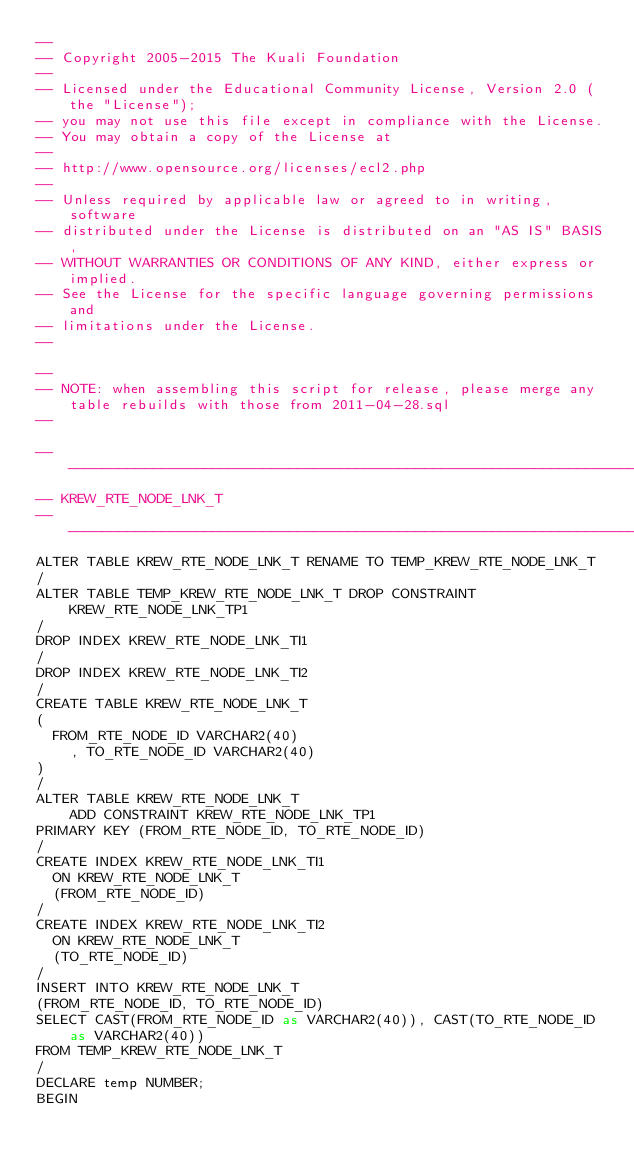Convert code to text. <code><loc_0><loc_0><loc_500><loc_500><_SQL_>--
-- Copyright 2005-2015 The Kuali Foundation
--
-- Licensed under the Educational Community License, Version 2.0 (the "License");
-- you may not use this file except in compliance with the License.
-- You may obtain a copy of the License at
--
-- http://www.opensource.org/licenses/ecl2.php
--
-- Unless required by applicable law or agreed to in writing, software
-- distributed under the License is distributed on an "AS IS" BASIS,
-- WITHOUT WARRANTIES OR CONDITIONS OF ANY KIND, either express or implied.
-- See the License for the specific language governing permissions and
-- limitations under the License.
--

--
-- NOTE: when assembling this script for release, please merge any table rebuilds with those from 2011-04-28.sql
--

-----------------------------------------------------------------------------
-- KREW_RTE_NODE_LNK_T
-----------------------------------------------------------------------------
ALTER TABLE KREW_RTE_NODE_LNK_T RENAME TO TEMP_KREW_RTE_NODE_LNK_T
/
ALTER TABLE TEMP_KREW_RTE_NODE_LNK_T DROP CONSTRAINT KREW_RTE_NODE_LNK_TP1
/
DROP INDEX KREW_RTE_NODE_LNK_TI1
/
DROP INDEX KREW_RTE_NODE_LNK_TI2
/
CREATE TABLE KREW_RTE_NODE_LNK_T
(
	FROM_RTE_NODE_ID VARCHAR2(40)
    , TO_RTE_NODE_ID VARCHAR2(40)
)
/
ALTER TABLE KREW_RTE_NODE_LNK_T
    ADD CONSTRAINT KREW_RTE_NODE_LNK_TP1
PRIMARY KEY (FROM_RTE_NODE_ID, TO_RTE_NODE_ID)
/
CREATE INDEX KREW_RTE_NODE_LNK_TI1 
  ON KREW_RTE_NODE_LNK_T 
  (FROM_RTE_NODE_ID)
/
CREATE INDEX KREW_RTE_NODE_LNK_TI2 
  ON KREW_RTE_NODE_LNK_T 
  (TO_RTE_NODE_ID)
/
INSERT INTO KREW_RTE_NODE_LNK_T
(FROM_RTE_NODE_ID, TO_RTE_NODE_ID)
SELECT CAST(FROM_RTE_NODE_ID as VARCHAR2(40)), CAST(TO_RTE_NODE_ID as VARCHAR2(40))
FROM TEMP_KREW_RTE_NODE_LNK_T
/
DECLARE temp NUMBER;
BEGIN</code> 